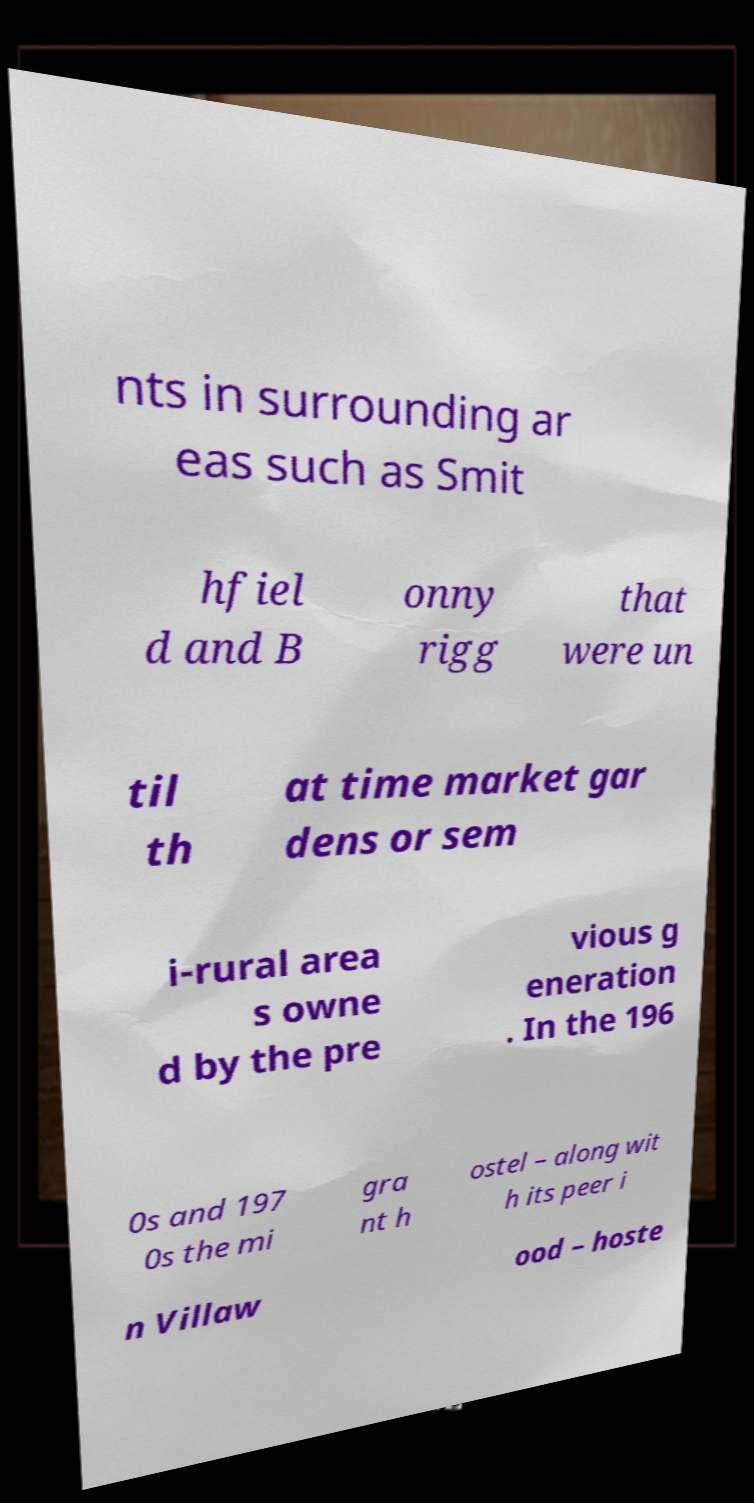Can you read and provide the text displayed in the image?This photo seems to have some interesting text. Can you extract and type it out for me? nts in surrounding ar eas such as Smit hfiel d and B onny rigg that were un til th at time market gar dens or sem i-rural area s owne d by the pre vious g eneration . In the 196 0s and 197 0s the mi gra nt h ostel – along wit h its peer i n Villaw ood – hoste 